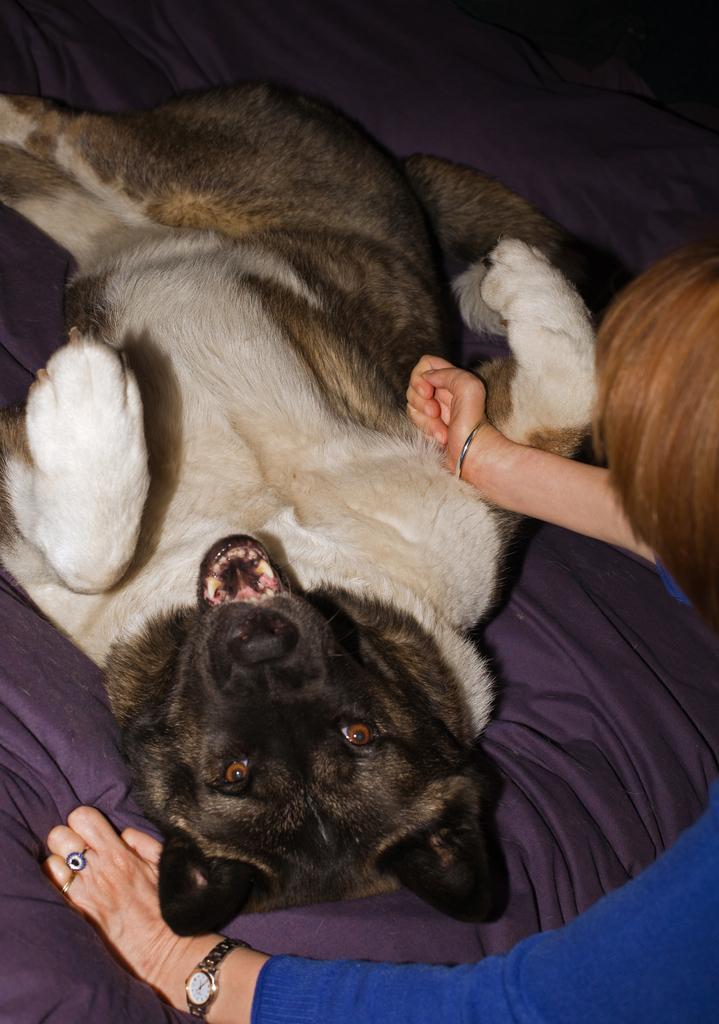Describe this image in one or two sentences. In this picture, we can see a person in the blue dress and in front of the person there is a dog laying on a bed. 